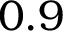<formula> <loc_0><loc_0><loc_500><loc_500>0 . 9</formula> 